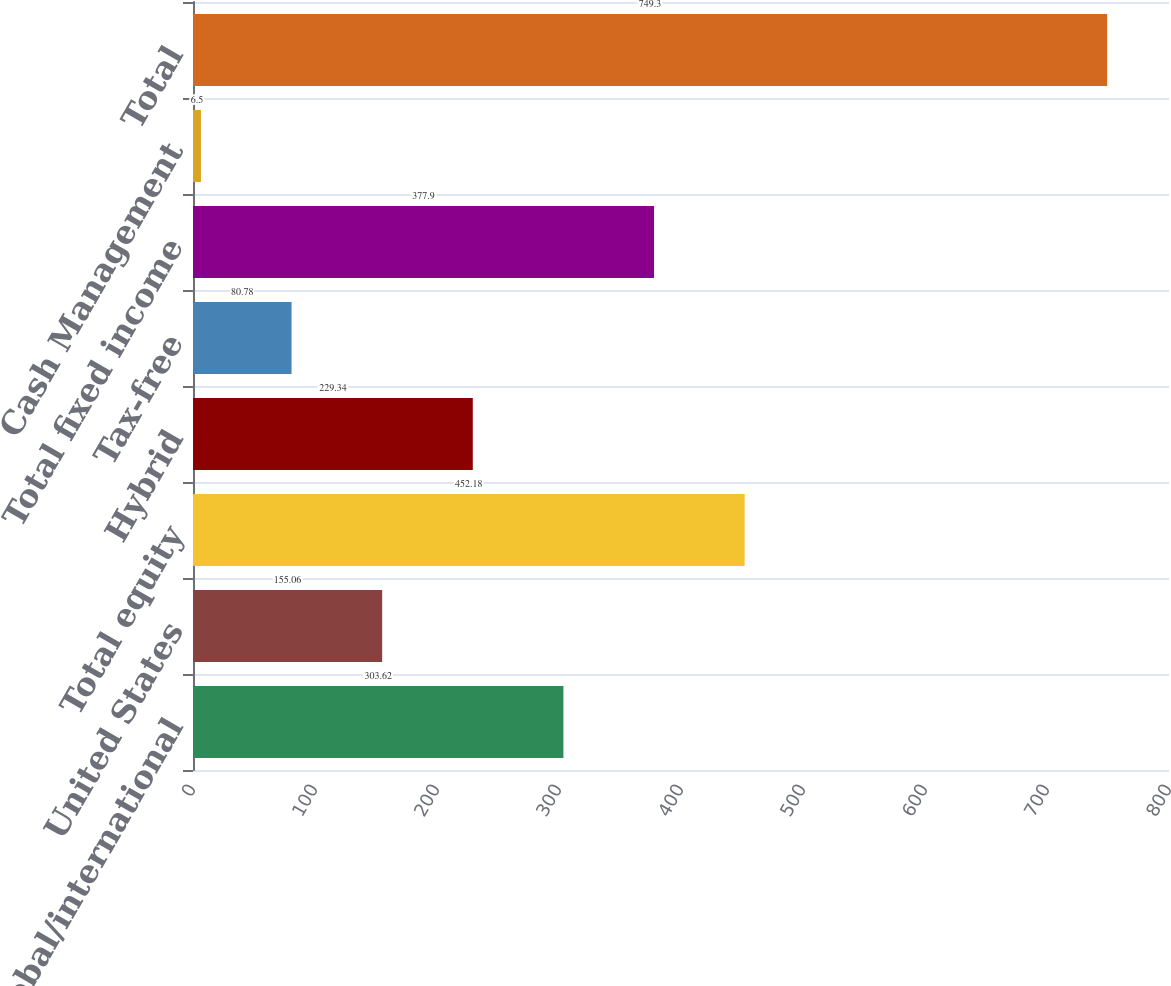Convert chart. <chart><loc_0><loc_0><loc_500><loc_500><bar_chart><fcel>Global/international<fcel>United States<fcel>Total equity<fcel>Hybrid<fcel>Tax-free<fcel>Total fixed income<fcel>Cash Management<fcel>Total<nl><fcel>303.62<fcel>155.06<fcel>452.18<fcel>229.34<fcel>80.78<fcel>377.9<fcel>6.5<fcel>749.3<nl></chart> 